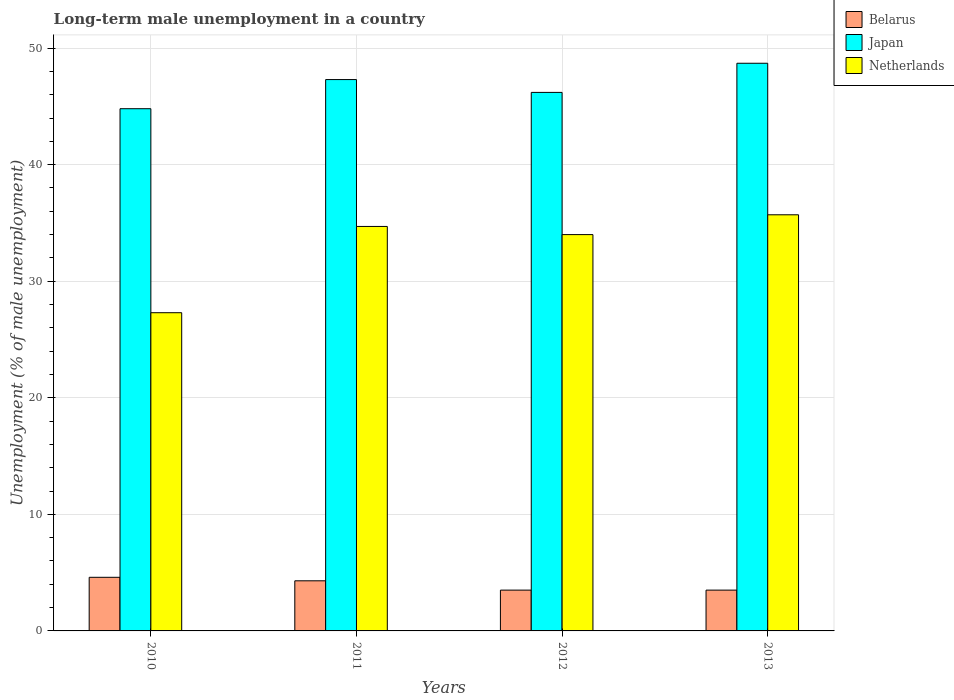How many different coloured bars are there?
Provide a succinct answer. 3. Are the number of bars per tick equal to the number of legend labels?
Keep it short and to the point. Yes. How many bars are there on the 3rd tick from the right?
Your answer should be compact. 3. What is the label of the 4th group of bars from the left?
Keep it short and to the point. 2013. In how many cases, is the number of bars for a given year not equal to the number of legend labels?
Your answer should be compact. 0. Across all years, what is the maximum percentage of long-term unemployed male population in Japan?
Offer a very short reply. 48.7. Across all years, what is the minimum percentage of long-term unemployed male population in Netherlands?
Give a very brief answer. 27.3. In which year was the percentage of long-term unemployed male population in Belarus maximum?
Make the answer very short. 2010. In which year was the percentage of long-term unemployed male population in Japan minimum?
Your answer should be very brief. 2010. What is the total percentage of long-term unemployed male population in Netherlands in the graph?
Offer a very short reply. 131.7. What is the difference between the percentage of long-term unemployed male population in Japan in 2010 and that in 2012?
Your response must be concise. -1.4. What is the difference between the percentage of long-term unemployed male population in Belarus in 2011 and the percentage of long-term unemployed male population in Japan in 2012?
Ensure brevity in your answer.  -41.9. What is the average percentage of long-term unemployed male population in Japan per year?
Ensure brevity in your answer.  46.75. In the year 2012, what is the difference between the percentage of long-term unemployed male population in Netherlands and percentage of long-term unemployed male population in Belarus?
Offer a terse response. 30.5. What is the ratio of the percentage of long-term unemployed male population in Japan in 2010 to that in 2012?
Provide a succinct answer. 0.97. Is the percentage of long-term unemployed male population in Netherlands in 2011 less than that in 2012?
Provide a short and direct response. No. What is the difference between the highest and the second highest percentage of long-term unemployed male population in Belarus?
Give a very brief answer. 0.3. What is the difference between the highest and the lowest percentage of long-term unemployed male population in Japan?
Your response must be concise. 3.9. Is the sum of the percentage of long-term unemployed male population in Belarus in 2010 and 2011 greater than the maximum percentage of long-term unemployed male population in Netherlands across all years?
Your response must be concise. No. What does the 2nd bar from the left in 2012 represents?
Make the answer very short. Japan. What does the 2nd bar from the right in 2012 represents?
Your answer should be very brief. Japan. Are all the bars in the graph horizontal?
Offer a very short reply. No. What is the difference between two consecutive major ticks on the Y-axis?
Offer a very short reply. 10. Are the values on the major ticks of Y-axis written in scientific E-notation?
Keep it short and to the point. No. Does the graph contain any zero values?
Give a very brief answer. No. Does the graph contain grids?
Provide a succinct answer. Yes. How many legend labels are there?
Your response must be concise. 3. How are the legend labels stacked?
Give a very brief answer. Vertical. What is the title of the graph?
Offer a terse response. Long-term male unemployment in a country. What is the label or title of the X-axis?
Your answer should be compact. Years. What is the label or title of the Y-axis?
Make the answer very short. Unemployment (% of male unemployment). What is the Unemployment (% of male unemployment) in Belarus in 2010?
Provide a succinct answer. 4.6. What is the Unemployment (% of male unemployment) of Japan in 2010?
Make the answer very short. 44.8. What is the Unemployment (% of male unemployment) of Netherlands in 2010?
Keep it short and to the point. 27.3. What is the Unemployment (% of male unemployment) of Belarus in 2011?
Offer a very short reply. 4.3. What is the Unemployment (% of male unemployment) of Japan in 2011?
Your answer should be very brief. 47.3. What is the Unemployment (% of male unemployment) of Netherlands in 2011?
Ensure brevity in your answer.  34.7. What is the Unemployment (% of male unemployment) of Belarus in 2012?
Your answer should be very brief. 3.5. What is the Unemployment (% of male unemployment) of Japan in 2012?
Keep it short and to the point. 46.2. What is the Unemployment (% of male unemployment) of Netherlands in 2012?
Give a very brief answer. 34. What is the Unemployment (% of male unemployment) of Japan in 2013?
Offer a terse response. 48.7. What is the Unemployment (% of male unemployment) in Netherlands in 2013?
Give a very brief answer. 35.7. Across all years, what is the maximum Unemployment (% of male unemployment) of Belarus?
Your response must be concise. 4.6. Across all years, what is the maximum Unemployment (% of male unemployment) in Japan?
Give a very brief answer. 48.7. Across all years, what is the maximum Unemployment (% of male unemployment) in Netherlands?
Your answer should be compact. 35.7. Across all years, what is the minimum Unemployment (% of male unemployment) of Belarus?
Your answer should be very brief. 3.5. Across all years, what is the minimum Unemployment (% of male unemployment) of Japan?
Make the answer very short. 44.8. Across all years, what is the minimum Unemployment (% of male unemployment) of Netherlands?
Ensure brevity in your answer.  27.3. What is the total Unemployment (% of male unemployment) of Belarus in the graph?
Provide a short and direct response. 15.9. What is the total Unemployment (% of male unemployment) in Japan in the graph?
Make the answer very short. 187. What is the total Unemployment (% of male unemployment) in Netherlands in the graph?
Your answer should be compact. 131.7. What is the difference between the Unemployment (% of male unemployment) in Belarus in 2010 and that in 2011?
Offer a terse response. 0.3. What is the difference between the Unemployment (% of male unemployment) of Japan in 2010 and that in 2011?
Provide a succinct answer. -2.5. What is the difference between the Unemployment (% of male unemployment) in Netherlands in 2010 and that in 2011?
Your answer should be compact. -7.4. What is the difference between the Unemployment (% of male unemployment) of Belarus in 2010 and that in 2013?
Provide a succinct answer. 1.1. What is the difference between the Unemployment (% of male unemployment) of Japan in 2010 and that in 2013?
Make the answer very short. -3.9. What is the difference between the Unemployment (% of male unemployment) of Japan in 2011 and that in 2012?
Your answer should be very brief. 1.1. What is the difference between the Unemployment (% of male unemployment) in Netherlands in 2011 and that in 2012?
Keep it short and to the point. 0.7. What is the difference between the Unemployment (% of male unemployment) in Belarus in 2011 and that in 2013?
Keep it short and to the point. 0.8. What is the difference between the Unemployment (% of male unemployment) of Japan in 2011 and that in 2013?
Provide a succinct answer. -1.4. What is the difference between the Unemployment (% of male unemployment) of Netherlands in 2011 and that in 2013?
Keep it short and to the point. -1. What is the difference between the Unemployment (% of male unemployment) of Belarus in 2012 and that in 2013?
Offer a terse response. 0. What is the difference between the Unemployment (% of male unemployment) of Netherlands in 2012 and that in 2013?
Keep it short and to the point. -1.7. What is the difference between the Unemployment (% of male unemployment) in Belarus in 2010 and the Unemployment (% of male unemployment) in Japan in 2011?
Your answer should be compact. -42.7. What is the difference between the Unemployment (% of male unemployment) in Belarus in 2010 and the Unemployment (% of male unemployment) in Netherlands in 2011?
Keep it short and to the point. -30.1. What is the difference between the Unemployment (% of male unemployment) in Japan in 2010 and the Unemployment (% of male unemployment) in Netherlands in 2011?
Make the answer very short. 10.1. What is the difference between the Unemployment (% of male unemployment) in Belarus in 2010 and the Unemployment (% of male unemployment) in Japan in 2012?
Offer a terse response. -41.6. What is the difference between the Unemployment (% of male unemployment) in Belarus in 2010 and the Unemployment (% of male unemployment) in Netherlands in 2012?
Ensure brevity in your answer.  -29.4. What is the difference between the Unemployment (% of male unemployment) in Japan in 2010 and the Unemployment (% of male unemployment) in Netherlands in 2012?
Your answer should be compact. 10.8. What is the difference between the Unemployment (% of male unemployment) of Belarus in 2010 and the Unemployment (% of male unemployment) of Japan in 2013?
Provide a succinct answer. -44.1. What is the difference between the Unemployment (% of male unemployment) in Belarus in 2010 and the Unemployment (% of male unemployment) in Netherlands in 2013?
Offer a very short reply. -31.1. What is the difference between the Unemployment (% of male unemployment) of Japan in 2010 and the Unemployment (% of male unemployment) of Netherlands in 2013?
Your response must be concise. 9.1. What is the difference between the Unemployment (% of male unemployment) of Belarus in 2011 and the Unemployment (% of male unemployment) of Japan in 2012?
Provide a short and direct response. -41.9. What is the difference between the Unemployment (% of male unemployment) of Belarus in 2011 and the Unemployment (% of male unemployment) of Netherlands in 2012?
Give a very brief answer. -29.7. What is the difference between the Unemployment (% of male unemployment) of Japan in 2011 and the Unemployment (% of male unemployment) of Netherlands in 2012?
Ensure brevity in your answer.  13.3. What is the difference between the Unemployment (% of male unemployment) in Belarus in 2011 and the Unemployment (% of male unemployment) in Japan in 2013?
Offer a terse response. -44.4. What is the difference between the Unemployment (% of male unemployment) of Belarus in 2011 and the Unemployment (% of male unemployment) of Netherlands in 2013?
Offer a very short reply. -31.4. What is the difference between the Unemployment (% of male unemployment) in Belarus in 2012 and the Unemployment (% of male unemployment) in Japan in 2013?
Keep it short and to the point. -45.2. What is the difference between the Unemployment (% of male unemployment) in Belarus in 2012 and the Unemployment (% of male unemployment) in Netherlands in 2013?
Your answer should be compact. -32.2. What is the difference between the Unemployment (% of male unemployment) in Japan in 2012 and the Unemployment (% of male unemployment) in Netherlands in 2013?
Give a very brief answer. 10.5. What is the average Unemployment (% of male unemployment) in Belarus per year?
Offer a very short reply. 3.98. What is the average Unemployment (% of male unemployment) in Japan per year?
Offer a terse response. 46.75. What is the average Unemployment (% of male unemployment) of Netherlands per year?
Your answer should be compact. 32.92. In the year 2010, what is the difference between the Unemployment (% of male unemployment) of Belarus and Unemployment (% of male unemployment) of Japan?
Keep it short and to the point. -40.2. In the year 2010, what is the difference between the Unemployment (% of male unemployment) in Belarus and Unemployment (% of male unemployment) in Netherlands?
Ensure brevity in your answer.  -22.7. In the year 2010, what is the difference between the Unemployment (% of male unemployment) of Japan and Unemployment (% of male unemployment) of Netherlands?
Ensure brevity in your answer.  17.5. In the year 2011, what is the difference between the Unemployment (% of male unemployment) in Belarus and Unemployment (% of male unemployment) in Japan?
Provide a short and direct response. -43. In the year 2011, what is the difference between the Unemployment (% of male unemployment) of Belarus and Unemployment (% of male unemployment) of Netherlands?
Your answer should be very brief. -30.4. In the year 2011, what is the difference between the Unemployment (% of male unemployment) of Japan and Unemployment (% of male unemployment) of Netherlands?
Your response must be concise. 12.6. In the year 2012, what is the difference between the Unemployment (% of male unemployment) of Belarus and Unemployment (% of male unemployment) of Japan?
Keep it short and to the point. -42.7. In the year 2012, what is the difference between the Unemployment (% of male unemployment) in Belarus and Unemployment (% of male unemployment) in Netherlands?
Provide a succinct answer. -30.5. In the year 2013, what is the difference between the Unemployment (% of male unemployment) of Belarus and Unemployment (% of male unemployment) of Japan?
Ensure brevity in your answer.  -45.2. In the year 2013, what is the difference between the Unemployment (% of male unemployment) of Belarus and Unemployment (% of male unemployment) of Netherlands?
Provide a short and direct response. -32.2. In the year 2013, what is the difference between the Unemployment (% of male unemployment) of Japan and Unemployment (% of male unemployment) of Netherlands?
Make the answer very short. 13. What is the ratio of the Unemployment (% of male unemployment) of Belarus in 2010 to that in 2011?
Provide a succinct answer. 1.07. What is the ratio of the Unemployment (% of male unemployment) of Japan in 2010 to that in 2011?
Provide a short and direct response. 0.95. What is the ratio of the Unemployment (% of male unemployment) of Netherlands in 2010 to that in 2011?
Ensure brevity in your answer.  0.79. What is the ratio of the Unemployment (% of male unemployment) in Belarus in 2010 to that in 2012?
Offer a very short reply. 1.31. What is the ratio of the Unemployment (% of male unemployment) of Japan in 2010 to that in 2012?
Ensure brevity in your answer.  0.97. What is the ratio of the Unemployment (% of male unemployment) of Netherlands in 2010 to that in 2012?
Provide a short and direct response. 0.8. What is the ratio of the Unemployment (% of male unemployment) of Belarus in 2010 to that in 2013?
Ensure brevity in your answer.  1.31. What is the ratio of the Unemployment (% of male unemployment) of Japan in 2010 to that in 2013?
Ensure brevity in your answer.  0.92. What is the ratio of the Unemployment (% of male unemployment) in Netherlands in 2010 to that in 2013?
Provide a succinct answer. 0.76. What is the ratio of the Unemployment (% of male unemployment) of Belarus in 2011 to that in 2012?
Provide a short and direct response. 1.23. What is the ratio of the Unemployment (% of male unemployment) of Japan in 2011 to that in 2012?
Provide a succinct answer. 1.02. What is the ratio of the Unemployment (% of male unemployment) in Netherlands in 2011 to that in 2012?
Provide a short and direct response. 1.02. What is the ratio of the Unemployment (% of male unemployment) in Belarus in 2011 to that in 2013?
Keep it short and to the point. 1.23. What is the ratio of the Unemployment (% of male unemployment) in Japan in 2011 to that in 2013?
Keep it short and to the point. 0.97. What is the ratio of the Unemployment (% of male unemployment) in Belarus in 2012 to that in 2013?
Your answer should be very brief. 1. What is the ratio of the Unemployment (% of male unemployment) in Japan in 2012 to that in 2013?
Provide a succinct answer. 0.95. What is the difference between the highest and the second highest Unemployment (% of male unemployment) in Japan?
Your response must be concise. 1.4. What is the difference between the highest and the lowest Unemployment (% of male unemployment) of Japan?
Keep it short and to the point. 3.9. What is the difference between the highest and the lowest Unemployment (% of male unemployment) in Netherlands?
Your answer should be very brief. 8.4. 